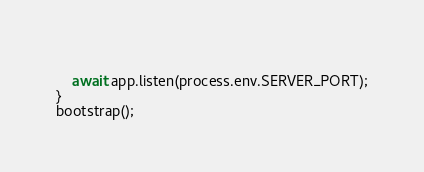<code> <loc_0><loc_0><loc_500><loc_500><_TypeScript_>    
    await app.listen(process.env.SERVER_PORT);
}
bootstrap();
</code> 